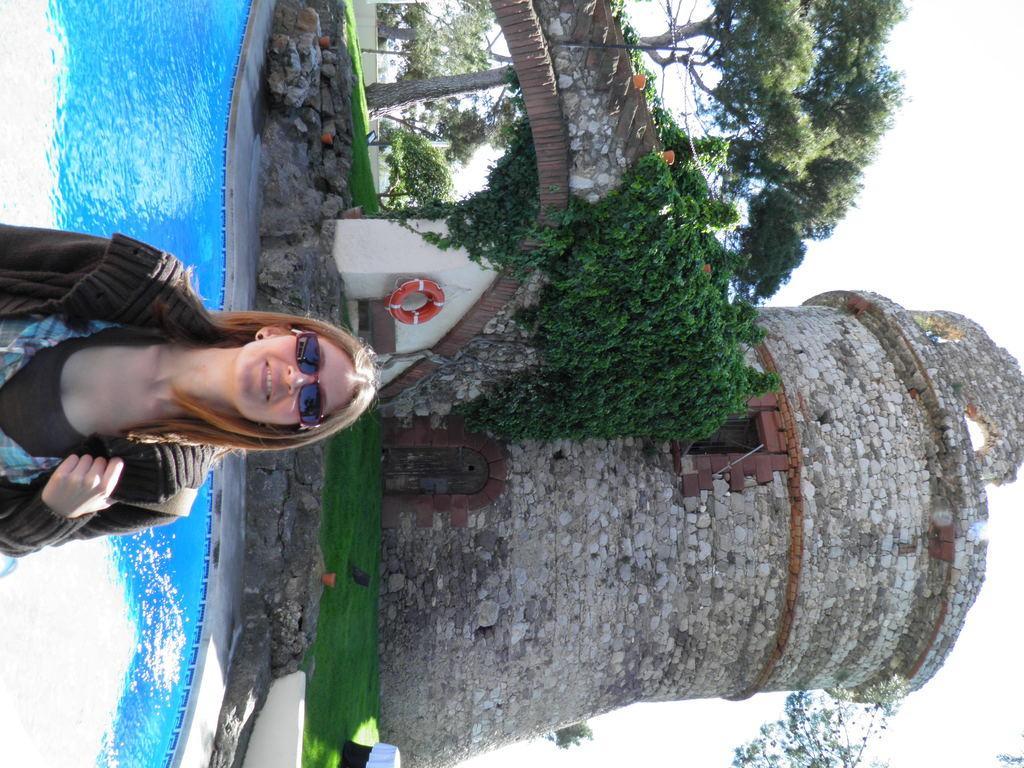Please provide a concise description of this image. In this image I can see a person standing wearing brown color shirt. Background I can see water in blue color, trees in green color and sky in white color. 